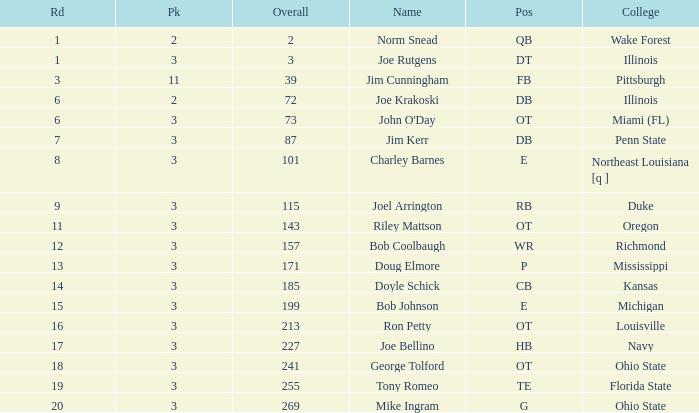How many rounds have john o'day as the name, and a pick less than 3? None. 